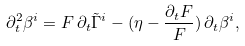<formula> <loc_0><loc_0><loc_500><loc_500>\partial ^ { 2 } _ { t } \beta ^ { i } = F \, \partial _ { t } \tilde { \Gamma } ^ { i } - ( \eta - \frac { \partial _ { t } F } { F } ) \, \partial _ { t } \beta ^ { i } ,</formula> 